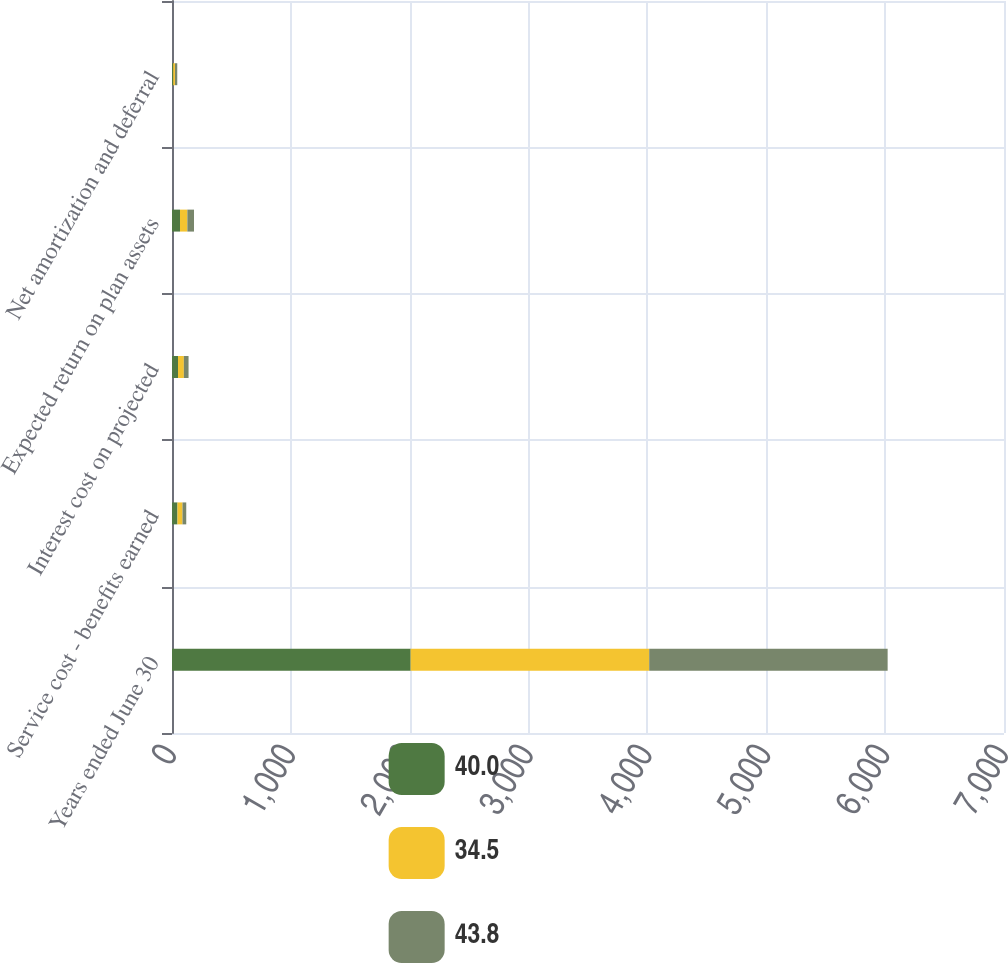Convert chart to OTSL. <chart><loc_0><loc_0><loc_500><loc_500><stacked_bar_chart><ecel><fcel>Years ended June 30<fcel>Service cost - benefits earned<fcel>Interest cost on projected<fcel>Expected return on plan assets<fcel>Net amortization and deferral<nl><fcel>40<fcel>2008<fcel>46.1<fcel>50.7<fcel>67.2<fcel>10.4<nl><fcel>34.5<fcel>2007<fcel>42.2<fcel>49<fcel>62<fcel>14.6<nl><fcel>43.8<fcel>2006<fcel>31.6<fcel>39.6<fcel>56<fcel>19.3<nl></chart> 